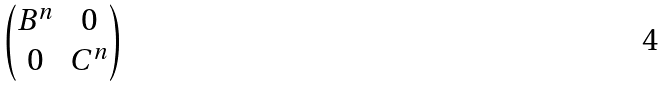<formula> <loc_0><loc_0><loc_500><loc_500>\begin{pmatrix} B ^ { n } & 0 \\ 0 & C ^ { n } \end{pmatrix}</formula> 